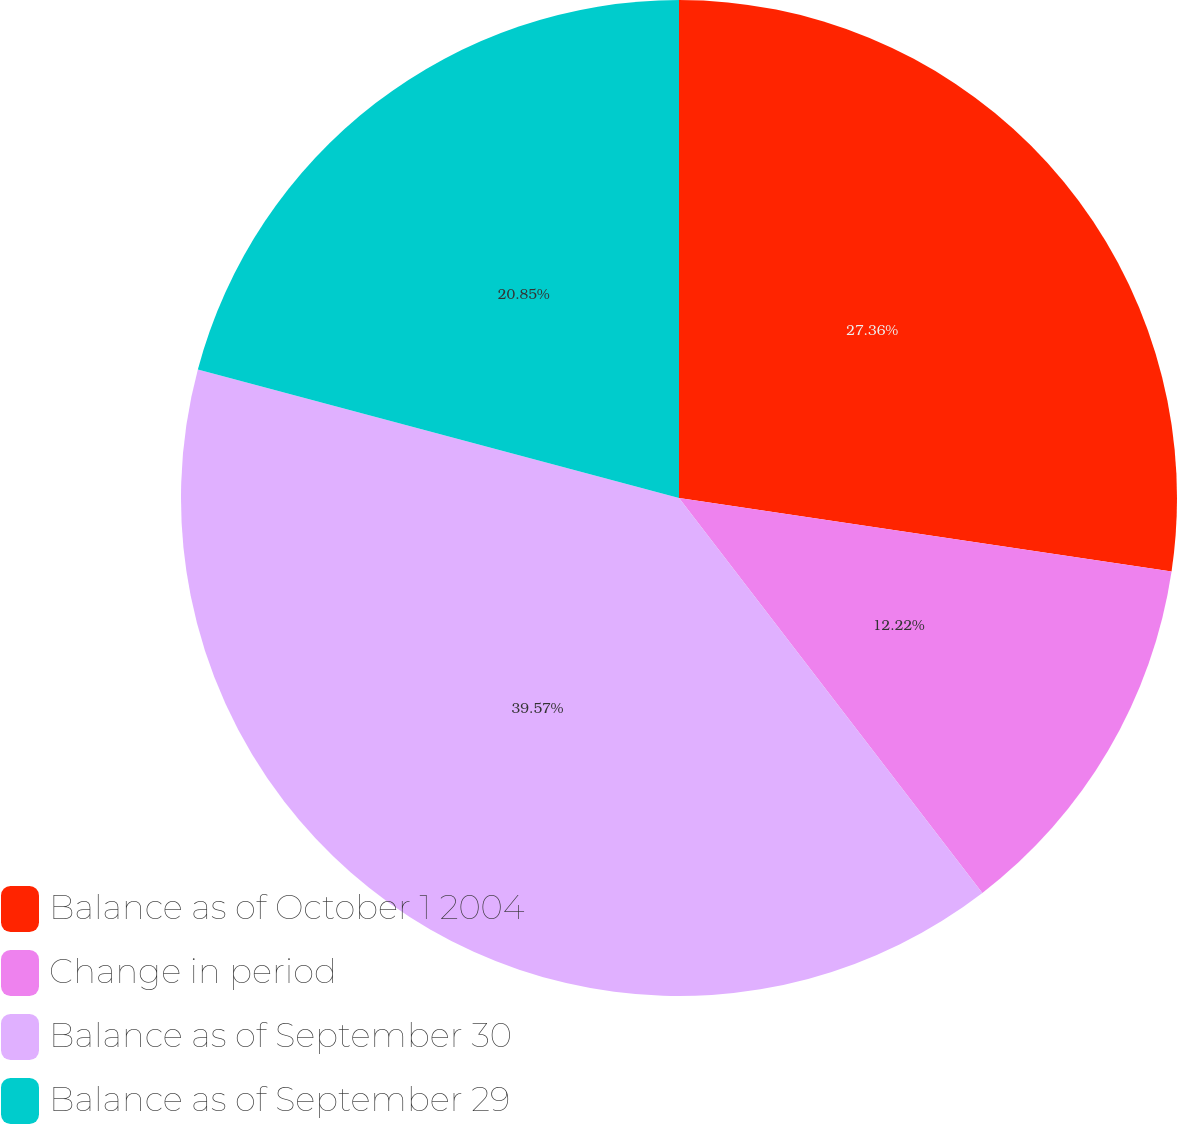Convert chart. <chart><loc_0><loc_0><loc_500><loc_500><pie_chart><fcel>Balance as of October 1 2004<fcel>Change in period<fcel>Balance as of September 30<fcel>Balance as of September 29<nl><fcel>27.36%<fcel>12.22%<fcel>39.58%<fcel>20.85%<nl></chart> 